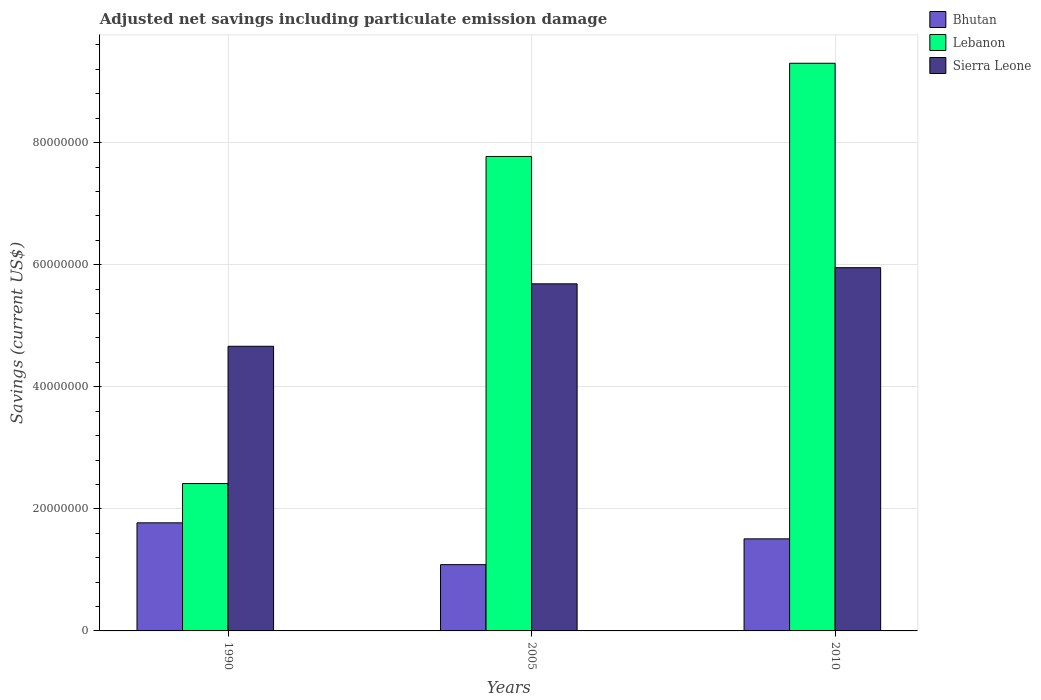How many different coloured bars are there?
Provide a short and direct response. 3. How many groups of bars are there?
Make the answer very short. 3. How many bars are there on the 1st tick from the left?
Your answer should be very brief. 3. How many bars are there on the 2nd tick from the right?
Your answer should be very brief. 3. What is the label of the 1st group of bars from the left?
Provide a short and direct response. 1990. In how many cases, is the number of bars for a given year not equal to the number of legend labels?
Offer a very short reply. 0. What is the net savings in Lebanon in 2010?
Offer a very short reply. 9.30e+07. Across all years, what is the maximum net savings in Lebanon?
Give a very brief answer. 9.30e+07. Across all years, what is the minimum net savings in Bhutan?
Your answer should be compact. 1.09e+07. What is the total net savings in Lebanon in the graph?
Provide a short and direct response. 1.95e+08. What is the difference between the net savings in Bhutan in 1990 and that in 2005?
Keep it short and to the point. 6.85e+06. What is the difference between the net savings in Sierra Leone in 2010 and the net savings in Bhutan in 2005?
Provide a succinct answer. 4.87e+07. What is the average net savings in Lebanon per year?
Offer a terse response. 6.50e+07. In the year 2010, what is the difference between the net savings in Bhutan and net savings in Lebanon?
Offer a terse response. -7.79e+07. What is the ratio of the net savings in Bhutan in 1990 to that in 2005?
Give a very brief answer. 1.63. Is the net savings in Bhutan in 1990 less than that in 2010?
Your answer should be very brief. No. Is the difference between the net savings in Bhutan in 2005 and 2010 greater than the difference between the net savings in Lebanon in 2005 and 2010?
Offer a terse response. Yes. What is the difference between the highest and the second highest net savings in Sierra Leone?
Provide a succinct answer. 2.64e+06. What is the difference between the highest and the lowest net savings in Bhutan?
Your answer should be compact. 6.85e+06. In how many years, is the net savings in Bhutan greater than the average net savings in Bhutan taken over all years?
Offer a terse response. 2. Is the sum of the net savings in Sierra Leone in 1990 and 2005 greater than the maximum net savings in Lebanon across all years?
Your answer should be very brief. Yes. What does the 3rd bar from the left in 1990 represents?
Provide a succinct answer. Sierra Leone. What does the 2nd bar from the right in 2005 represents?
Make the answer very short. Lebanon. How many bars are there?
Make the answer very short. 9. Are all the bars in the graph horizontal?
Provide a succinct answer. No. Does the graph contain any zero values?
Your answer should be very brief. No. Does the graph contain grids?
Make the answer very short. Yes. How are the legend labels stacked?
Make the answer very short. Vertical. What is the title of the graph?
Your answer should be very brief. Adjusted net savings including particulate emission damage. Does "Macao" appear as one of the legend labels in the graph?
Provide a short and direct response. No. What is the label or title of the Y-axis?
Your answer should be very brief. Savings (current US$). What is the Savings (current US$) of Bhutan in 1990?
Make the answer very short. 1.77e+07. What is the Savings (current US$) of Lebanon in 1990?
Provide a succinct answer. 2.41e+07. What is the Savings (current US$) of Sierra Leone in 1990?
Provide a short and direct response. 4.66e+07. What is the Savings (current US$) of Bhutan in 2005?
Ensure brevity in your answer.  1.09e+07. What is the Savings (current US$) in Lebanon in 2005?
Keep it short and to the point. 7.77e+07. What is the Savings (current US$) of Sierra Leone in 2005?
Offer a very short reply. 5.69e+07. What is the Savings (current US$) in Bhutan in 2010?
Your answer should be compact. 1.51e+07. What is the Savings (current US$) of Lebanon in 2010?
Provide a short and direct response. 9.30e+07. What is the Savings (current US$) in Sierra Leone in 2010?
Offer a terse response. 5.95e+07. Across all years, what is the maximum Savings (current US$) of Bhutan?
Ensure brevity in your answer.  1.77e+07. Across all years, what is the maximum Savings (current US$) of Lebanon?
Offer a terse response. 9.30e+07. Across all years, what is the maximum Savings (current US$) in Sierra Leone?
Your response must be concise. 5.95e+07. Across all years, what is the minimum Savings (current US$) in Bhutan?
Your answer should be very brief. 1.09e+07. Across all years, what is the minimum Savings (current US$) in Lebanon?
Provide a short and direct response. 2.41e+07. Across all years, what is the minimum Savings (current US$) in Sierra Leone?
Provide a succinct answer. 4.66e+07. What is the total Savings (current US$) of Bhutan in the graph?
Offer a terse response. 4.36e+07. What is the total Savings (current US$) of Lebanon in the graph?
Provide a short and direct response. 1.95e+08. What is the total Savings (current US$) in Sierra Leone in the graph?
Offer a terse response. 1.63e+08. What is the difference between the Savings (current US$) in Bhutan in 1990 and that in 2005?
Your answer should be very brief. 6.85e+06. What is the difference between the Savings (current US$) in Lebanon in 1990 and that in 2005?
Your answer should be very brief. -5.36e+07. What is the difference between the Savings (current US$) in Sierra Leone in 1990 and that in 2005?
Keep it short and to the point. -1.02e+07. What is the difference between the Savings (current US$) of Bhutan in 1990 and that in 2010?
Provide a short and direct response. 2.62e+06. What is the difference between the Savings (current US$) in Lebanon in 1990 and that in 2010?
Make the answer very short. -6.89e+07. What is the difference between the Savings (current US$) of Sierra Leone in 1990 and that in 2010?
Your response must be concise. -1.29e+07. What is the difference between the Savings (current US$) in Bhutan in 2005 and that in 2010?
Keep it short and to the point. -4.23e+06. What is the difference between the Savings (current US$) in Lebanon in 2005 and that in 2010?
Your response must be concise. -1.53e+07. What is the difference between the Savings (current US$) in Sierra Leone in 2005 and that in 2010?
Offer a terse response. -2.64e+06. What is the difference between the Savings (current US$) in Bhutan in 1990 and the Savings (current US$) in Lebanon in 2005?
Offer a very short reply. -6.00e+07. What is the difference between the Savings (current US$) in Bhutan in 1990 and the Savings (current US$) in Sierra Leone in 2005?
Keep it short and to the point. -3.92e+07. What is the difference between the Savings (current US$) in Lebanon in 1990 and the Savings (current US$) in Sierra Leone in 2005?
Give a very brief answer. -3.27e+07. What is the difference between the Savings (current US$) in Bhutan in 1990 and the Savings (current US$) in Lebanon in 2010?
Your response must be concise. -7.53e+07. What is the difference between the Savings (current US$) of Bhutan in 1990 and the Savings (current US$) of Sierra Leone in 2010?
Provide a short and direct response. -4.18e+07. What is the difference between the Savings (current US$) of Lebanon in 1990 and the Savings (current US$) of Sierra Leone in 2010?
Ensure brevity in your answer.  -3.54e+07. What is the difference between the Savings (current US$) in Bhutan in 2005 and the Savings (current US$) in Lebanon in 2010?
Your answer should be compact. -8.21e+07. What is the difference between the Savings (current US$) of Bhutan in 2005 and the Savings (current US$) of Sierra Leone in 2010?
Your answer should be compact. -4.87e+07. What is the difference between the Savings (current US$) in Lebanon in 2005 and the Savings (current US$) in Sierra Leone in 2010?
Your answer should be compact. 1.82e+07. What is the average Savings (current US$) of Bhutan per year?
Your answer should be very brief. 1.45e+07. What is the average Savings (current US$) in Lebanon per year?
Ensure brevity in your answer.  6.50e+07. What is the average Savings (current US$) of Sierra Leone per year?
Give a very brief answer. 5.43e+07. In the year 1990, what is the difference between the Savings (current US$) of Bhutan and Savings (current US$) of Lebanon?
Your answer should be very brief. -6.44e+06. In the year 1990, what is the difference between the Savings (current US$) of Bhutan and Savings (current US$) of Sierra Leone?
Provide a succinct answer. -2.89e+07. In the year 1990, what is the difference between the Savings (current US$) in Lebanon and Savings (current US$) in Sierra Leone?
Offer a very short reply. -2.25e+07. In the year 2005, what is the difference between the Savings (current US$) in Bhutan and Savings (current US$) in Lebanon?
Offer a very short reply. -6.69e+07. In the year 2005, what is the difference between the Savings (current US$) of Bhutan and Savings (current US$) of Sierra Leone?
Your response must be concise. -4.60e+07. In the year 2005, what is the difference between the Savings (current US$) of Lebanon and Savings (current US$) of Sierra Leone?
Your answer should be compact. 2.09e+07. In the year 2010, what is the difference between the Savings (current US$) in Bhutan and Savings (current US$) in Lebanon?
Give a very brief answer. -7.79e+07. In the year 2010, what is the difference between the Savings (current US$) of Bhutan and Savings (current US$) of Sierra Leone?
Make the answer very short. -4.44e+07. In the year 2010, what is the difference between the Savings (current US$) of Lebanon and Savings (current US$) of Sierra Leone?
Make the answer very short. 3.35e+07. What is the ratio of the Savings (current US$) of Bhutan in 1990 to that in 2005?
Your answer should be compact. 1.63. What is the ratio of the Savings (current US$) of Lebanon in 1990 to that in 2005?
Offer a terse response. 0.31. What is the ratio of the Savings (current US$) in Sierra Leone in 1990 to that in 2005?
Give a very brief answer. 0.82. What is the ratio of the Savings (current US$) in Bhutan in 1990 to that in 2010?
Give a very brief answer. 1.17. What is the ratio of the Savings (current US$) in Lebanon in 1990 to that in 2010?
Your answer should be compact. 0.26. What is the ratio of the Savings (current US$) in Sierra Leone in 1990 to that in 2010?
Provide a short and direct response. 0.78. What is the ratio of the Savings (current US$) in Bhutan in 2005 to that in 2010?
Keep it short and to the point. 0.72. What is the ratio of the Savings (current US$) in Lebanon in 2005 to that in 2010?
Your response must be concise. 0.84. What is the ratio of the Savings (current US$) in Sierra Leone in 2005 to that in 2010?
Provide a short and direct response. 0.96. What is the difference between the highest and the second highest Savings (current US$) of Bhutan?
Keep it short and to the point. 2.62e+06. What is the difference between the highest and the second highest Savings (current US$) in Lebanon?
Provide a short and direct response. 1.53e+07. What is the difference between the highest and the second highest Savings (current US$) in Sierra Leone?
Offer a terse response. 2.64e+06. What is the difference between the highest and the lowest Savings (current US$) of Bhutan?
Your response must be concise. 6.85e+06. What is the difference between the highest and the lowest Savings (current US$) in Lebanon?
Provide a short and direct response. 6.89e+07. What is the difference between the highest and the lowest Savings (current US$) in Sierra Leone?
Give a very brief answer. 1.29e+07. 